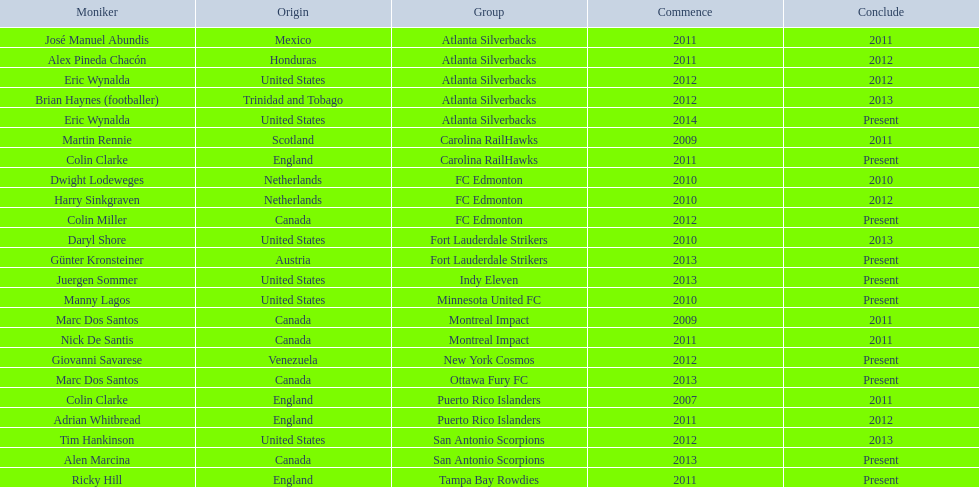What year did marc dos santos start as coach? 2009. Besides marc dos santos, what other coach started in 2009? Martin Rennie. 